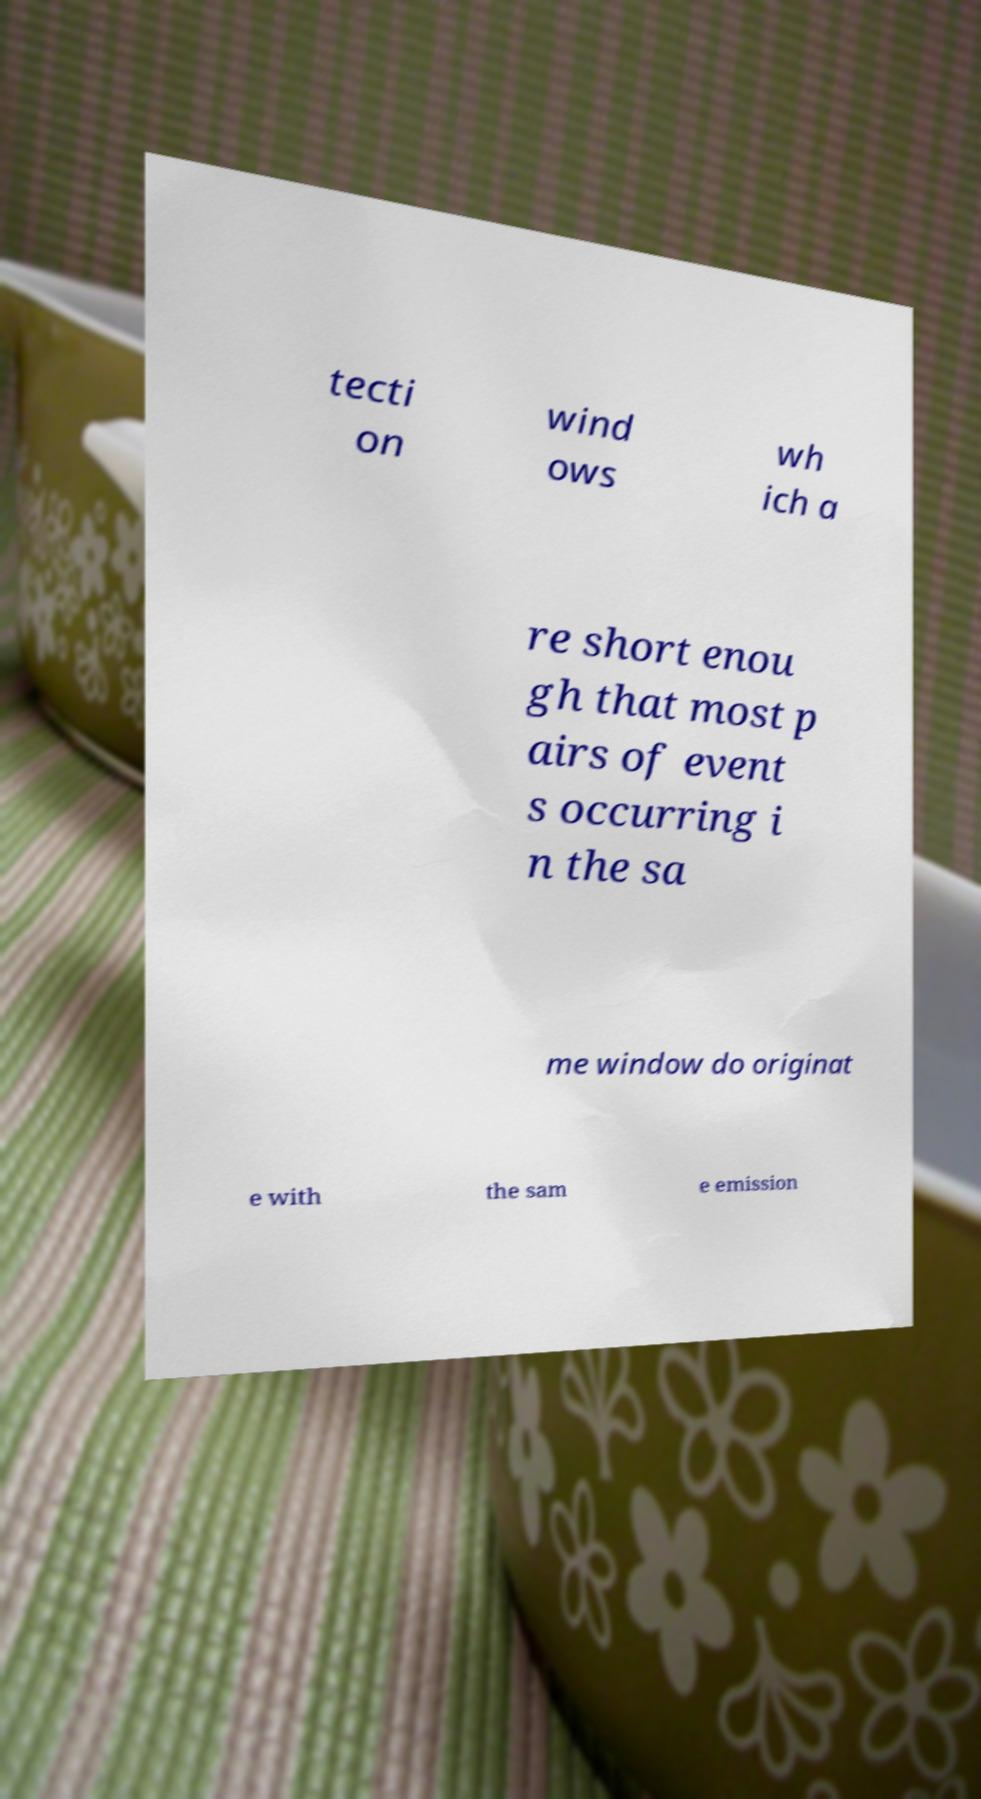For documentation purposes, I need the text within this image transcribed. Could you provide that? tecti on wind ows wh ich a re short enou gh that most p airs of event s occurring i n the sa me window do originat e with the sam e emission 